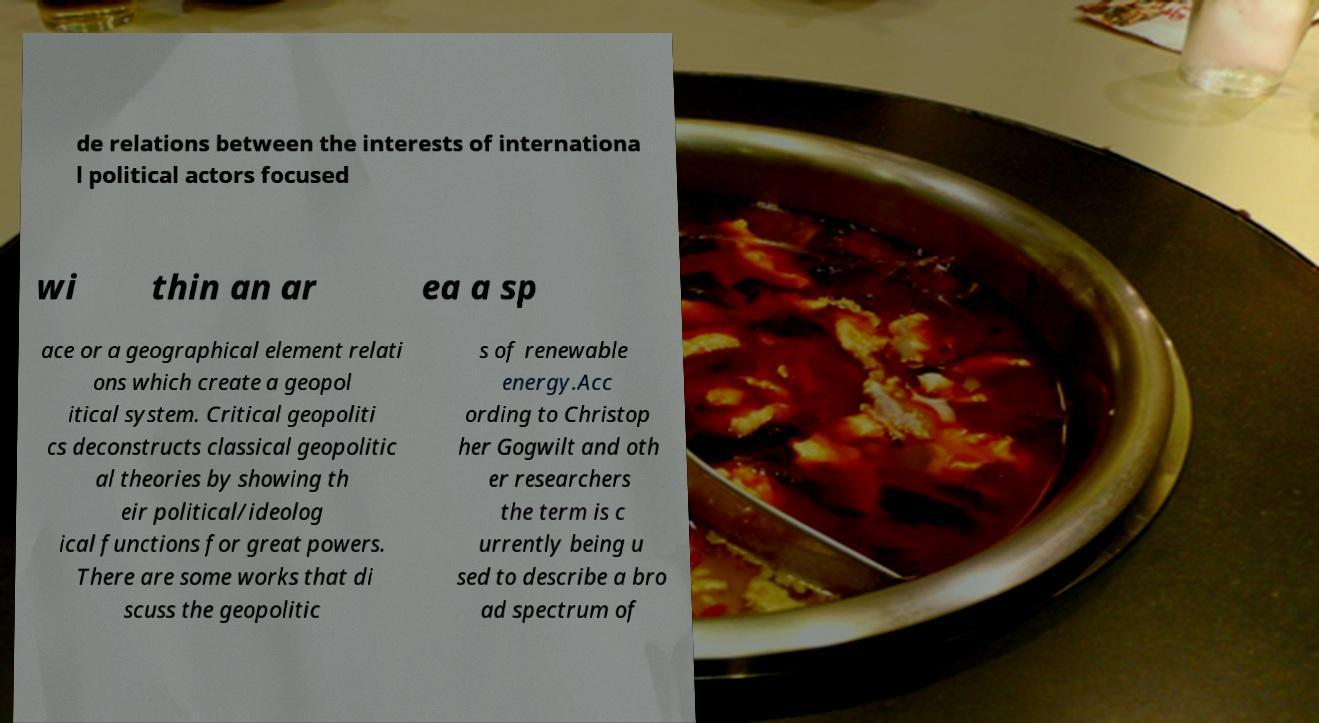Could you extract and type out the text from this image? de relations between the interests of internationa l political actors focused wi thin an ar ea a sp ace or a geographical element relati ons which create a geopol itical system. Critical geopoliti cs deconstructs classical geopolitic al theories by showing th eir political/ideolog ical functions for great powers. There are some works that di scuss the geopolitic s of renewable energy.Acc ording to Christop her Gogwilt and oth er researchers the term is c urrently being u sed to describe a bro ad spectrum of 